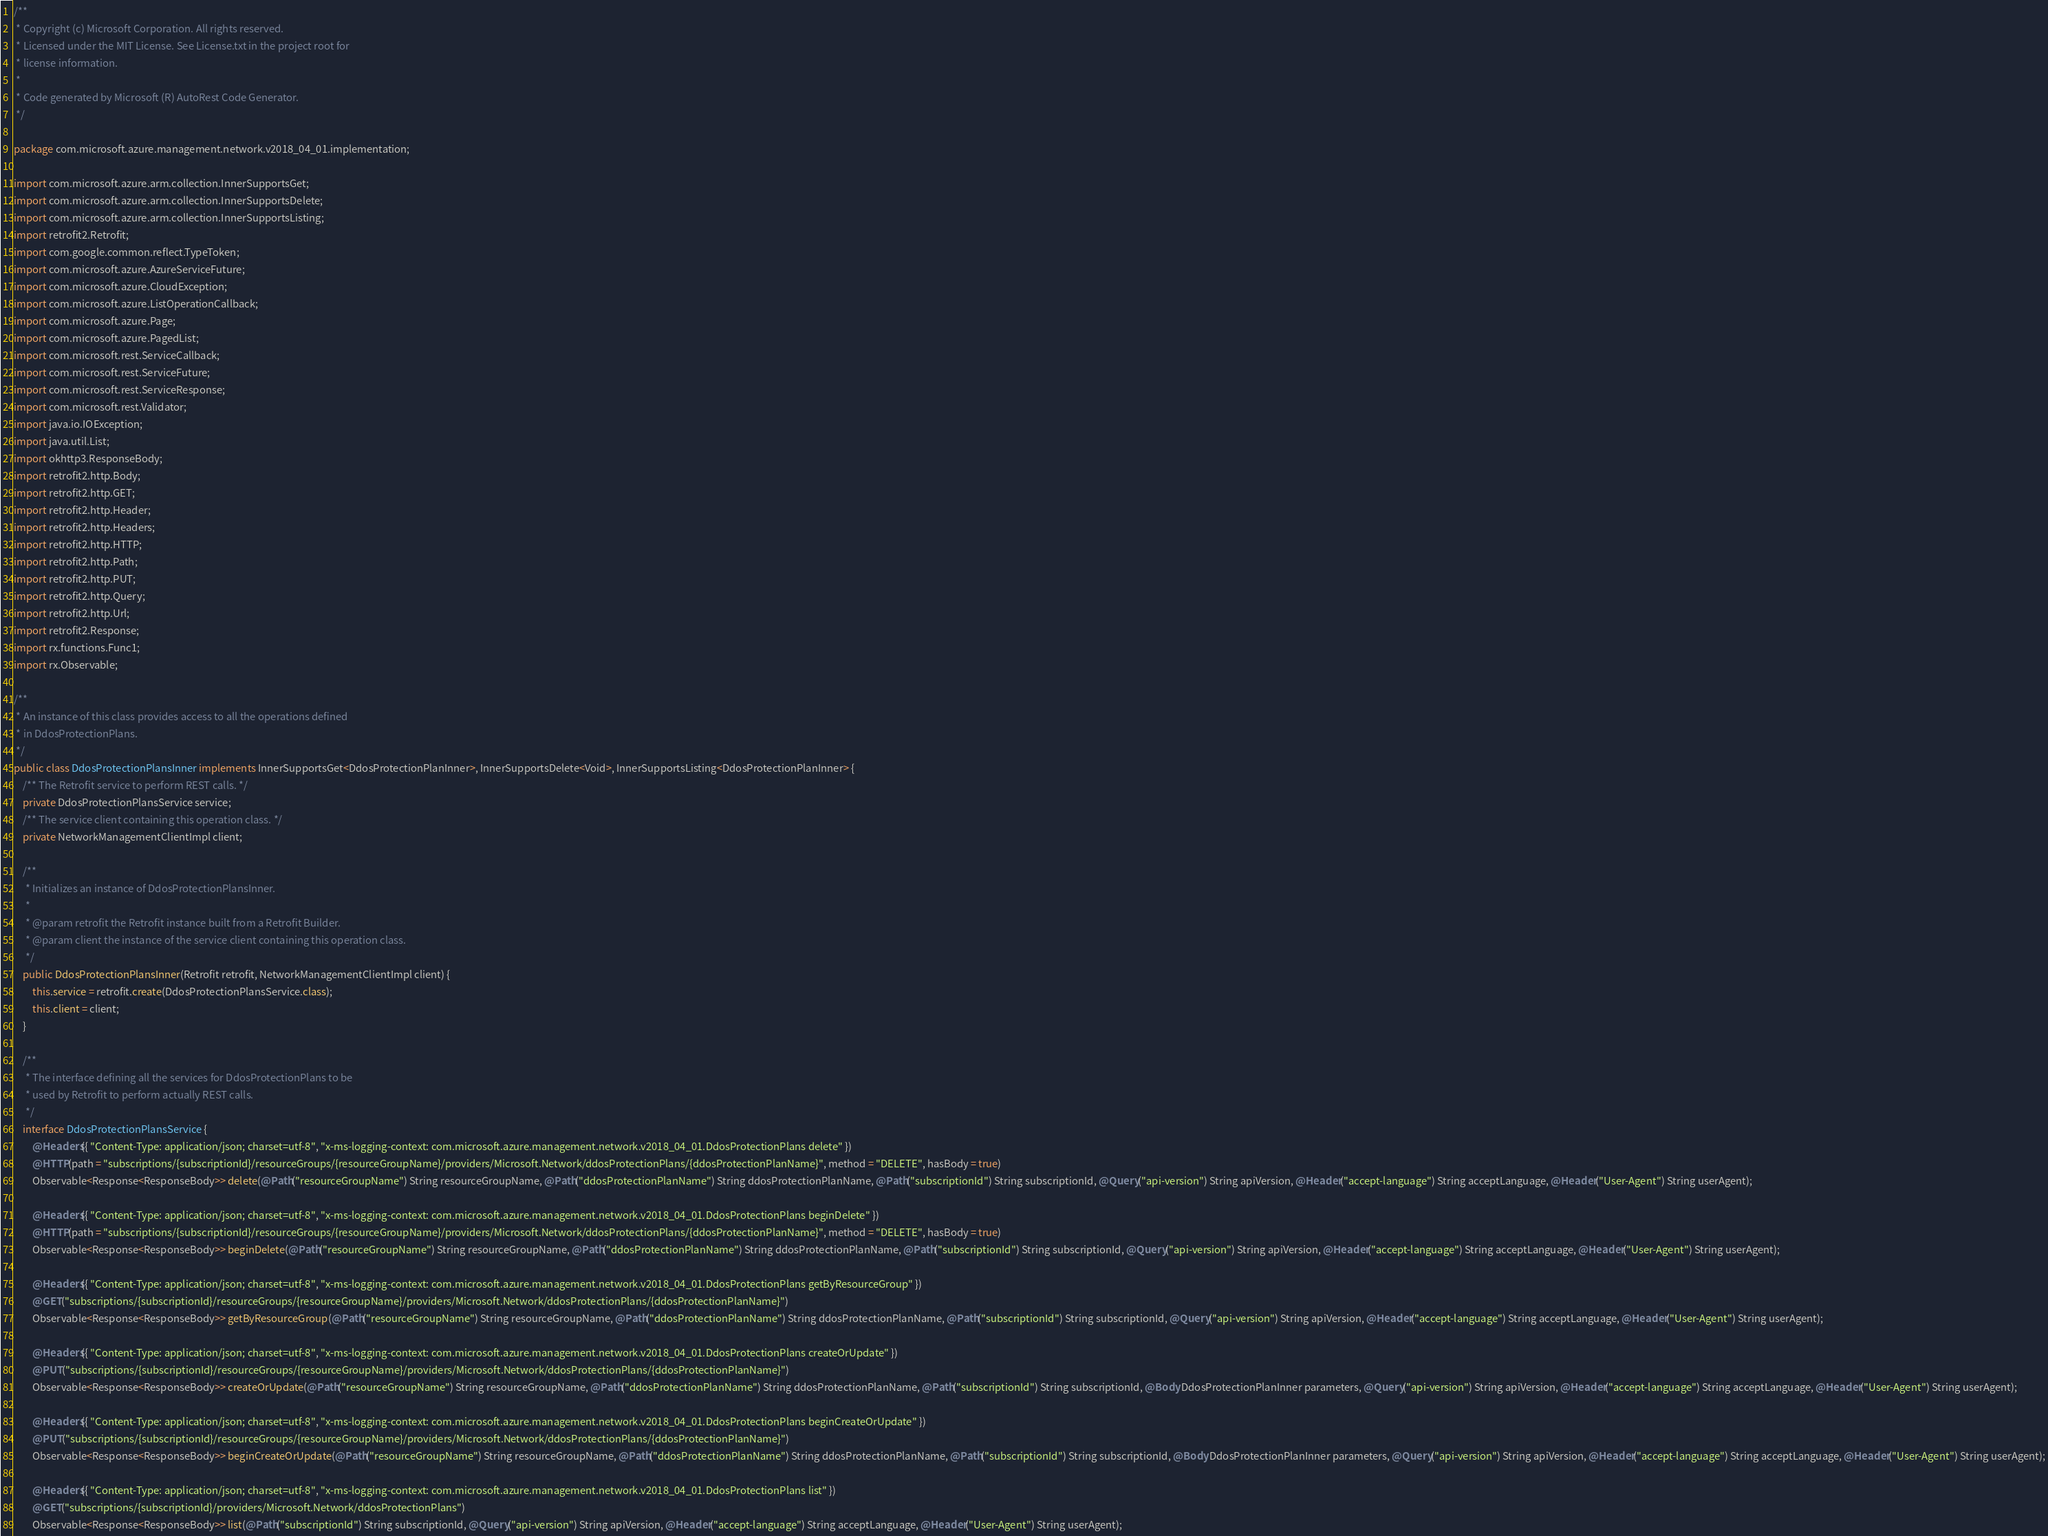<code> <loc_0><loc_0><loc_500><loc_500><_Java_>/**
 * Copyright (c) Microsoft Corporation. All rights reserved.
 * Licensed under the MIT License. See License.txt in the project root for
 * license information.
 *
 * Code generated by Microsoft (R) AutoRest Code Generator.
 */

package com.microsoft.azure.management.network.v2018_04_01.implementation;

import com.microsoft.azure.arm.collection.InnerSupportsGet;
import com.microsoft.azure.arm.collection.InnerSupportsDelete;
import com.microsoft.azure.arm.collection.InnerSupportsListing;
import retrofit2.Retrofit;
import com.google.common.reflect.TypeToken;
import com.microsoft.azure.AzureServiceFuture;
import com.microsoft.azure.CloudException;
import com.microsoft.azure.ListOperationCallback;
import com.microsoft.azure.Page;
import com.microsoft.azure.PagedList;
import com.microsoft.rest.ServiceCallback;
import com.microsoft.rest.ServiceFuture;
import com.microsoft.rest.ServiceResponse;
import com.microsoft.rest.Validator;
import java.io.IOException;
import java.util.List;
import okhttp3.ResponseBody;
import retrofit2.http.Body;
import retrofit2.http.GET;
import retrofit2.http.Header;
import retrofit2.http.Headers;
import retrofit2.http.HTTP;
import retrofit2.http.Path;
import retrofit2.http.PUT;
import retrofit2.http.Query;
import retrofit2.http.Url;
import retrofit2.Response;
import rx.functions.Func1;
import rx.Observable;

/**
 * An instance of this class provides access to all the operations defined
 * in DdosProtectionPlans.
 */
public class DdosProtectionPlansInner implements InnerSupportsGet<DdosProtectionPlanInner>, InnerSupportsDelete<Void>, InnerSupportsListing<DdosProtectionPlanInner> {
    /** The Retrofit service to perform REST calls. */
    private DdosProtectionPlansService service;
    /** The service client containing this operation class. */
    private NetworkManagementClientImpl client;

    /**
     * Initializes an instance of DdosProtectionPlansInner.
     *
     * @param retrofit the Retrofit instance built from a Retrofit Builder.
     * @param client the instance of the service client containing this operation class.
     */
    public DdosProtectionPlansInner(Retrofit retrofit, NetworkManagementClientImpl client) {
        this.service = retrofit.create(DdosProtectionPlansService.class);
        this.client = client;
    }

    /**
     * The interface defining all the services for DdosProtectionPlans to be
     * used by Retrofit to perform actually REST calls.
     */
    interface DdosProtectionPlansService {
        @Headers({ "Content-Type: application/json; charset=utf-8", "x-ms-logging-context: com.microsoft.azure.management.network.v2018_04_01.DdosProtectionPlans delete" })
        @HTTP(path = "subscriptions/{subscriptionId}/resourceGroups/{resourceGroupName}/providers/Microsoft.Network/ddosProtectionPlans/{ddosProtectionPlanName}", method = "DELETE", hasBody = true)
        Observable<Response<ResponseBody>> delete(@Path("resourceGroupName") String resourceGroupName, @Path("ddosProtectionPlanName") String ddosProtectionPlanName, @Path("subscriptionId") String subscriptionId, @Query("api-version") String apiVersion, @Header("accept-language") String acceptLanguage, @Header("User-Agent") String userAgent);

        @Headers({ "Content-Type: application/json; charset=utf-8", "x-ms-logging-context: com.microsoft.azure.management.network.v2018_04_01.DdosProtectionPlans beginDelete" })
        @HTTP(path = "subscriptions/{subscriptionId}/resourceGroups/{resourceGroupName}/providers/Microsoft.Network/ddosProtectionPlans/{ddosProtectionPlanName}", method = "DELETE", hasBody = true)
        Observable<Response<ResponseBody>> beginDelete(@Path("resourceGroupName") String resourceGroupName, @Path("ddosProtectionPlanName") String ddosProtectionPlanName, @Path("subscriptionId") String subscriptionId, @Query("api-version") String apiVersion, @Header("accept-language") String acceptLanguage, @Header("User-Agent") String userAgent);

        @Headers({ "Content-Type: application/json; charset=utf-8", "x-ms-logging-context: com.microsoft.azure.management.network.v2018_04_01.DdosProtectionPlans getByResourceGroup" })
        @GET("subscriptions/{subscriptionId}/resourceGroups/{resourceGroupName}/providers/Microsoft.Network/ddosProtectionPlans/{ddosProtectionPlanName}")
        Observable<Response<ResponseBody>> getByResourceGroup(@Path("resourceGroupName") String resourceGroupName, @Path("ddosProtectionPlanName") String ddosProtectionPlanName, @Path("subscriptionId") String subscriptionId, @Query("api-version") String apiVersion, @Header("accept-language") String acceptLanguage, @Header("User-Agent") String userAgent);

        @Headers({ "Content-Type: application/json; charset=utf-8", "x-ms-logging-context: com.microsoft.azure.management.network.v2018_04_01.DdosProtectionPlans createOrUpdate" })
        @PUT("subscriptions/{subscriptionId}/resourceGroups/{resourceGroupName}/providers/Microsoft.Network/ddosProtectionPlans/{ddosProtectionPlanName}")
        Observable<Response<ResponseBody>> createOrUpdate(@Path("resourceGroupName") String resourceGroupName, @Path("ddosProtectionPlanName") String ddosProtectionPlanName, @Path("subscriptionId") String subscriptionId, @Body DdosProtectionPlanInner parameters, @Query("api-version") String apiVersion, @Header("accept-language") String acceptLanguage, @Header("User-Agent") String userAgent);

        @Headers({ "Content-Type: application/json; charset=utf-8", "x-ms-logging-context: com.microsoft.azure.management.network.v2018_04_01.DdosProtectionPlans beginCreateOrUpdate" })
        @PUT("subscriptions/{subscriptionId}/resourceGroups/{resourceGroupName}/providers/Microsoft.Network/ddosProtectionPlans/{ddosProtectionPlanName}")
        Observable<Response<ResponseBody>> beginCreateOrUpdate(@Path("resourceGroupName") String resourceGroupName, @Path("ddosProtectionPlanName") String ddosProtectionPlanName, @Path("subscriptionId") String subscriptionId, @Body DdosProtectionPlanInner parameters, @Query("api-version") String apiVersion, @Header("accept-language") String acceptLanguage, @Header("User-Agent") String userAgent);

        @Headers({ "Content-Type: application/json; charset=utf-8", "x-ms-logging-context: com.microsoft.azure.management.network.v2018_04_01.DdosProtectionPlans list" })
        @GET("subscriptions/{subscriptionId}/providers/Microsoft.Network/ddosProtectionPlans")
        Observable<Response<ResponseBody>> list(@Path("subscriptionId") String subscriptionId, @Query("api-version") String apiVersion, @Header("accept-language") String acceptLanguage, @Header("User-Agent") String userAgent);
</code> 